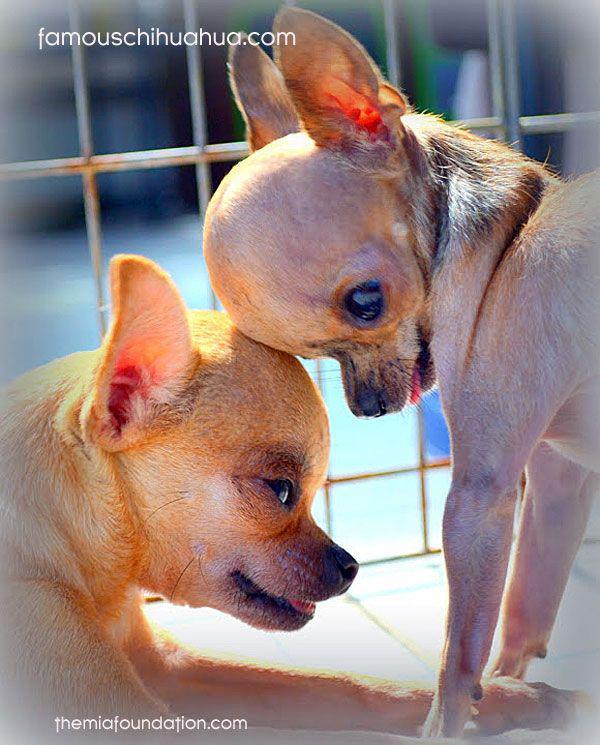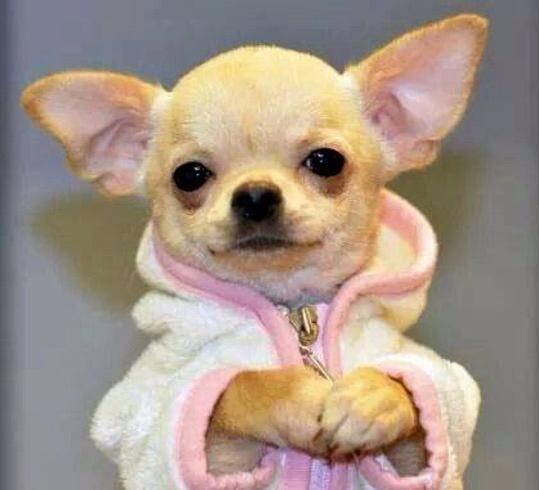The first image is the image on the left, the second image is the image on the right. Given the left and right images, does the statement "The dog in the image on the left is wearing a collar." hold true? Answer yes or no. No. The first image is the image on the left, the second image is the image on the right. Analyze the images presented: Is the assertion "One dog is wearing the kind of item people wear." valid? Answer yes or no. Yes. 